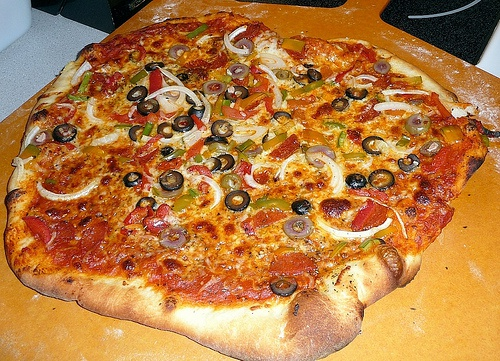Describe the objects in this image and their specific colors. I can see a pizza in darkgray, red, tan, and brown tones in this image. 